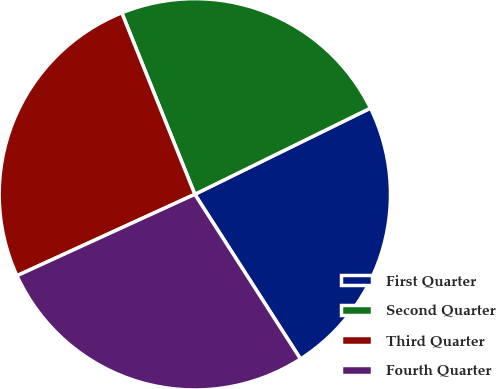Convert chart. <chart><loc_0><loc_0><loc_500><loc_500><pie_chart><fcel>First Quarter<fcel>Second Quarter<fcel>Third Quarter<fcel>Fourth Quarter<nl><fcel>23.18%<fcel>23.83%<fcel>25.74%<fcel>27.25%<nl></chart> 